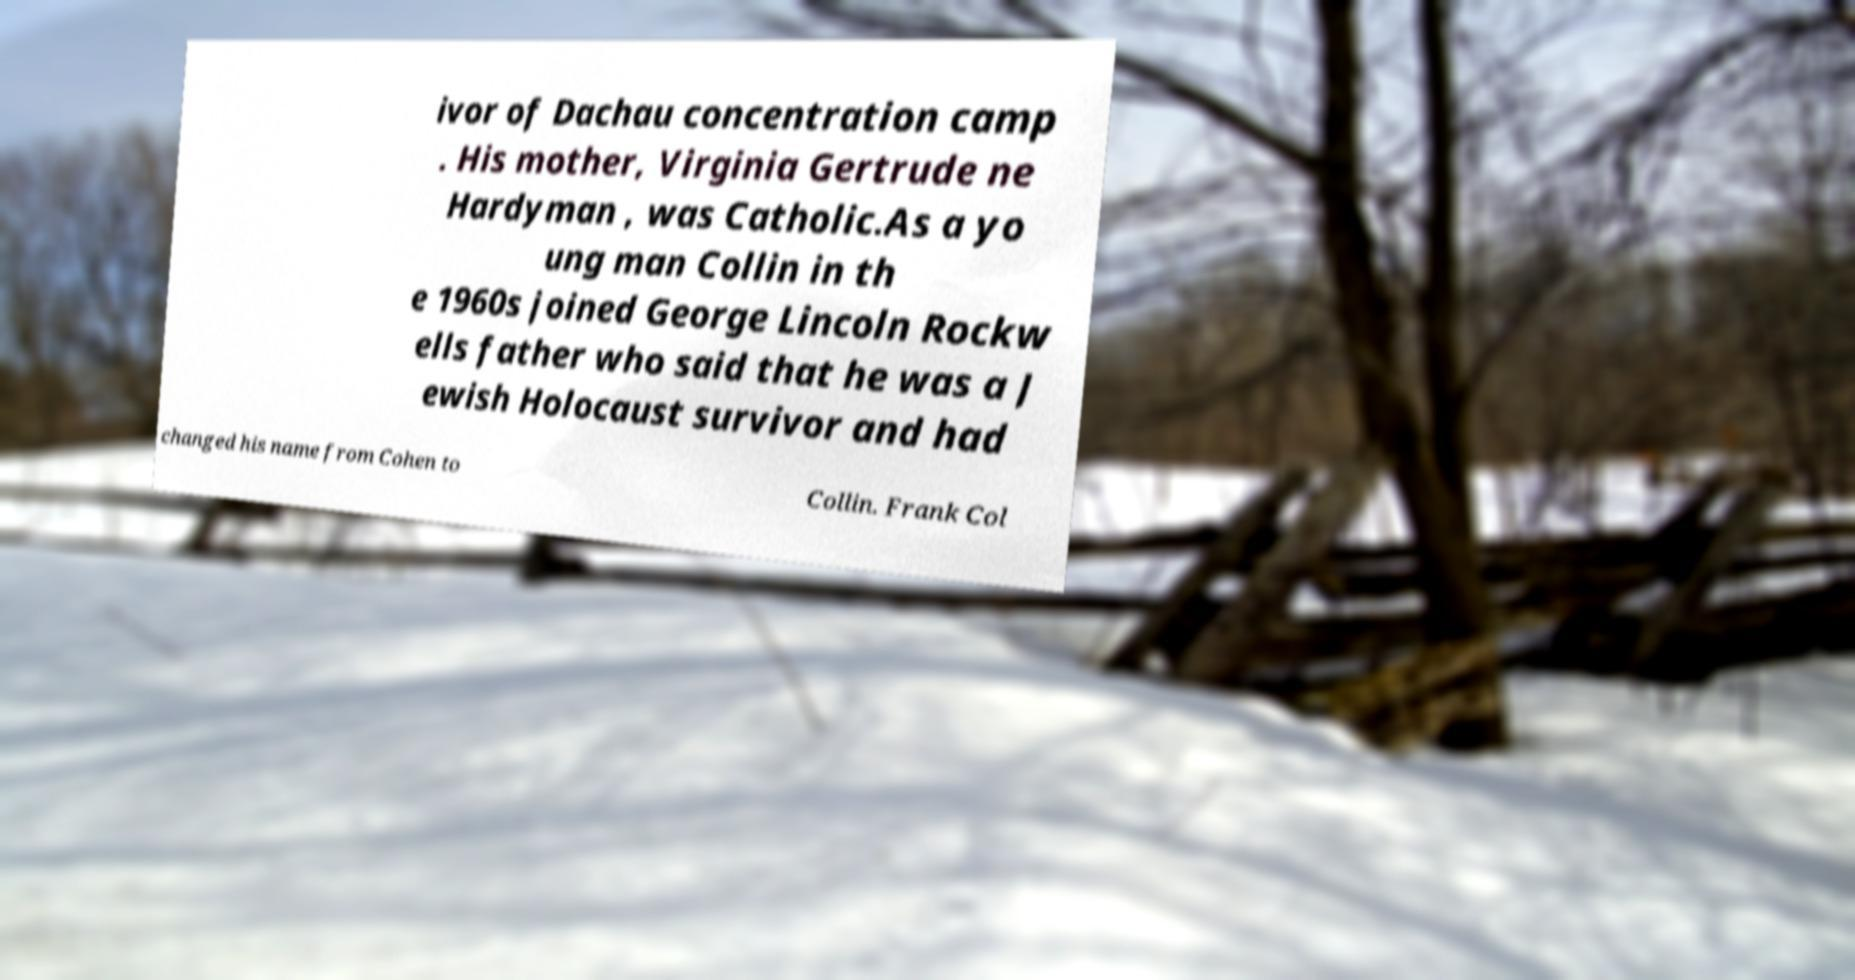What messages or text are displayed in this image? I need them in a readable, typed format. ivor of Dachau concentration camp . His mother, Virginia Gertrude ne Hardyman , was Catholic.As a yo ung man Collin in th e 1960s joined George Lincoln Rockw ells father who said that he was a J ewish Holocaust survivor and had changed his name from Cohen to Collin. Frank Col 